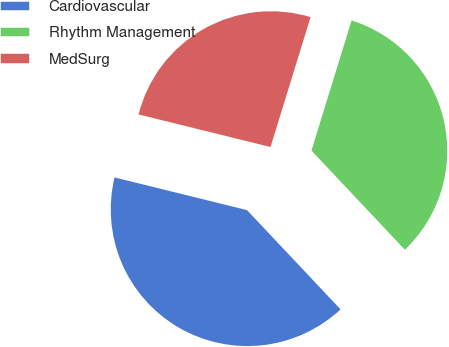Convert chart to OTSL. <chart><loc_0><loc_0><loc_500><loc_500><pie_chart><fcel>Cardiovascular<fcel>Rhythm Management<fcel>MedSurg<nl><fcel>40.88%<fcel>33.21%<fcel>25.91%<nl></chart> 